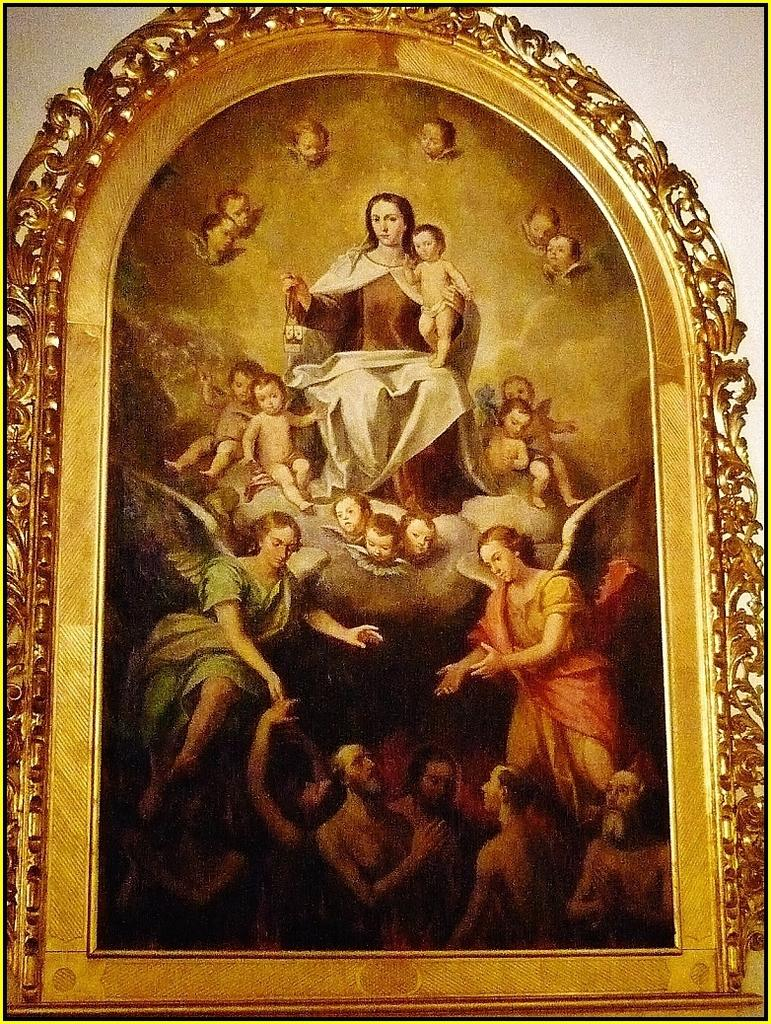What object is present in the image that typically holds a picture? There is a photo frame in the image. What can be seen inside the photo frame? The photo frame contains a picture of people. What type of shirt is the person in the photo wearing? There is no shirt visible in the image, as it only shows a photo frame containing a picture of people. 